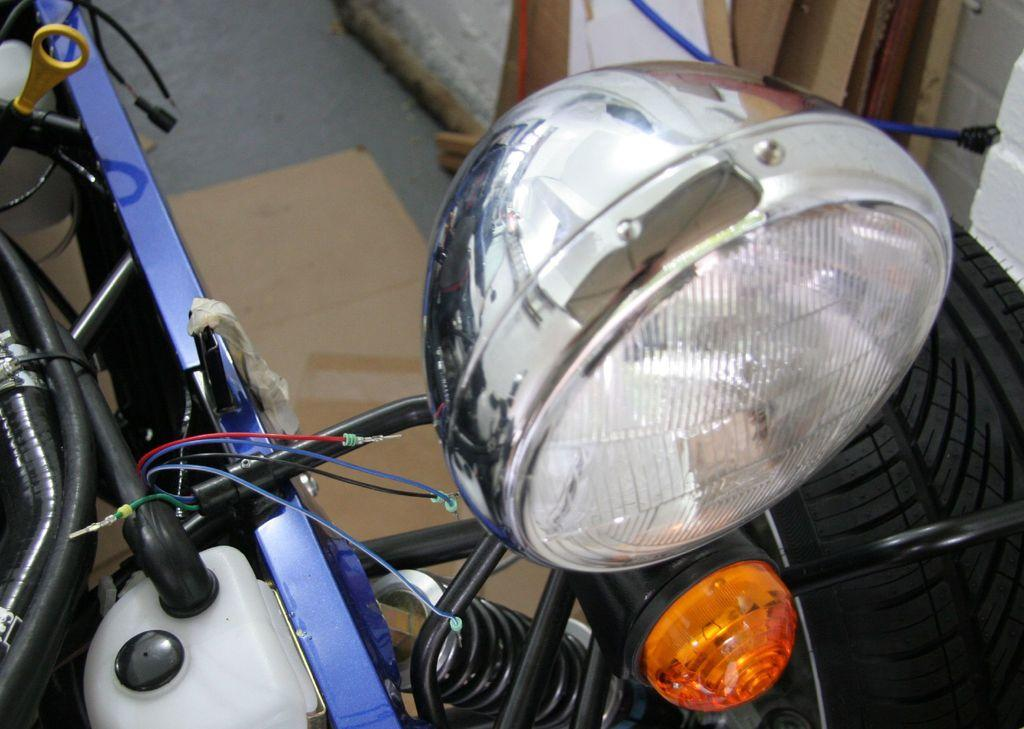What is the main subject in the image? There is a vehicle in the image. Can you describe the background of the image? There is a wall in the background of the image. How many men are attacking the vehicle in the image? There are no men or attacks present in the image; it only features a vehicle and a wall in the background. 